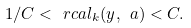<formula> <loc_0><loc_0><loc_500><loc_500>1 / C < \ r c a l _ { k } ( y , \ a ) < C .</formula> 